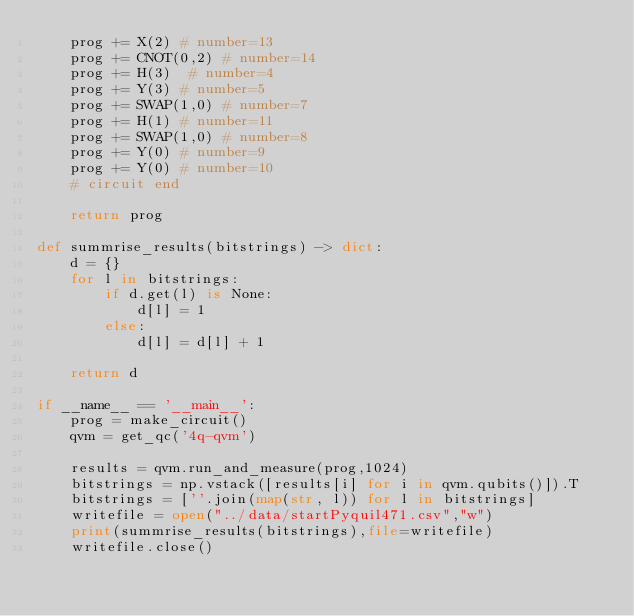Convert code to text. <code><loc_0><loc_0><loc_500><loc_500><_Python_>    prog += X(2) # number=13
    prog += CNOT(0,2) # number=14
    prog += H(3)  # number=4
    prog += Y(3) # number=5
    prog += SWAP(1,0) # number=7
    prog += H(1) # number=11
    prog += SWAP(1,0) # number=8
    prog += Y(0) # number=9
    prog += Y(0) # number=10
    # circuit end

    return prog

def summrise_results(bitstrings) -> dict:
    d = {}
    for l in bitstrings:
        if d.get(l) is None:
            d[l] = 1
        else:
            d[l] = d[l] + 1

    return d

if __name__ == '__main__':
    prog = make_circuit()
    qvm = get_qc('4q-qvm')

    results = qvm.run_and_measure(prog,1024)
    bitstrings = np.vstack([results[i] for i in qvm.qubits()]).T
    bitstrings = [''.join(map(str, l)) for l in bitstrings]
    writefile = open("../data/startPyquil471.csv","w")
    print(summrise_results(bitstrings),file=writefile)
    writefile.close()

</code> 